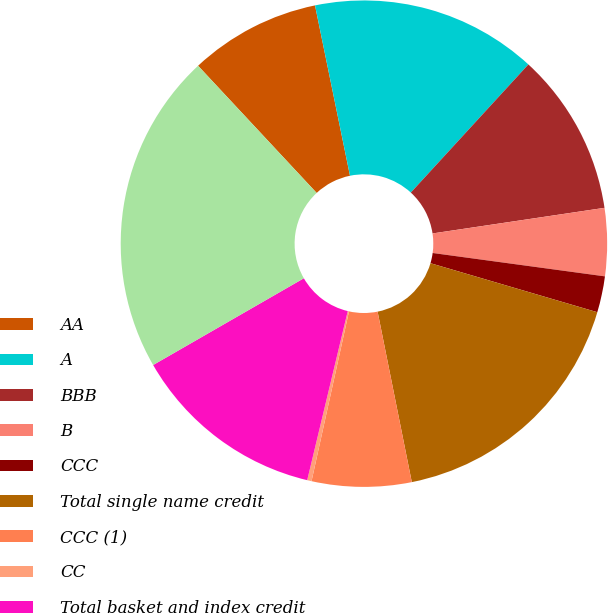Convert chart. <chart><loc_0><loc_0><loc_500><loc_500><pie_chart><fcel>AA<fcel>A<fcel>BBB<fcel>B<fcel>CCC<fcel>Total single name credit<fcel>CCC (1)<fcel>CC<fcel>Total basket and index credit<fcel>Total credit default swap<nl><fcel>8.72%<fcel>15.04%<fcel>10.83%<fcel>4.5%<fcel>2.4%<fcel>17.3%<fcel>6.61%<fcel>0.29%<fcel>12.94%<fcel>21.37%<nl></chart> 